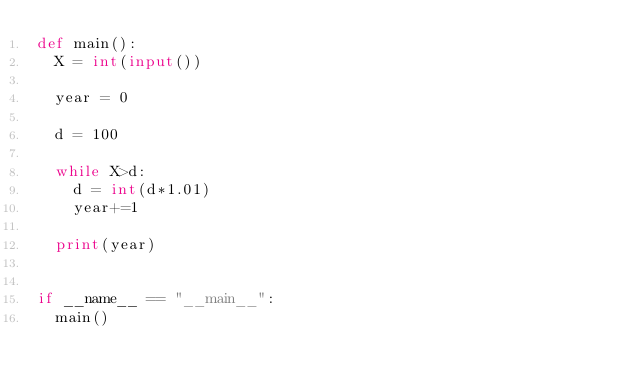<code> <loc_0><loc_0><loc_500><loc_500><_Python_>def main():
  X = int(input())

  year = 0

  d = 100

  while X>d:
    d = int(d*1.01)
    year+=1

  print(year)


if __name__ == "__main__":
  main()</code> 